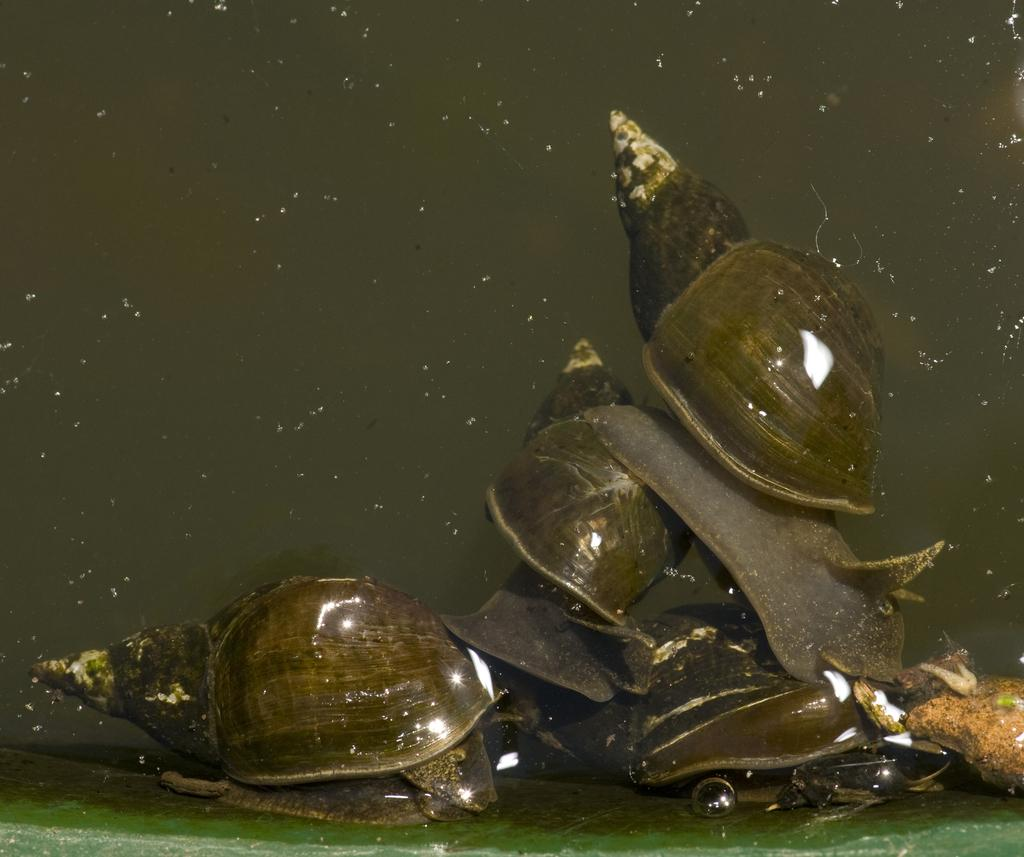What type of objects can be seen in the image? There are shells in the image. Can you describe the appearance of the shells? The shells have a unique, spiral-like shape and may have different colors and patterns. What might be the origin of these shells? The shells could have come from the ocean or a body of water where shellfish live. What type of suggestion is being made by the shells in the image? There is no suggestion being made by the shells in the image, as they are inanimate objects. 